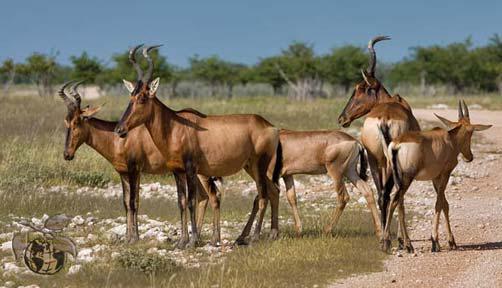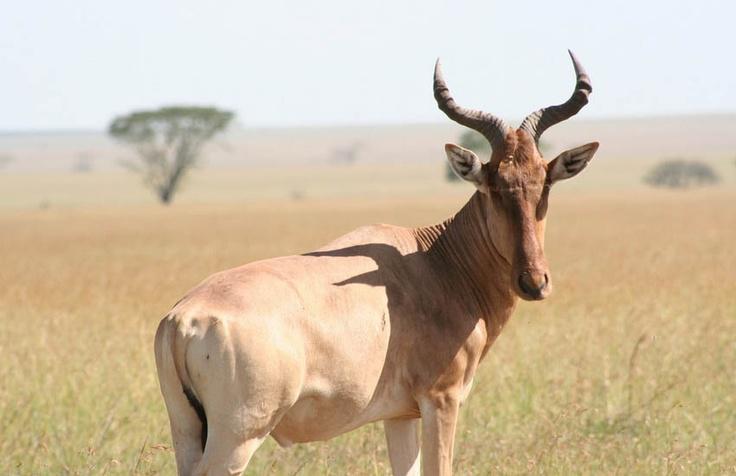The first image is the image on the left, the second image is the image on the right. Considering the images on both sides, is "The right image contains one horned animal with its body turned rightward, and the left image contains at least five horned animals." valid? Answer yes or no. Yes. 